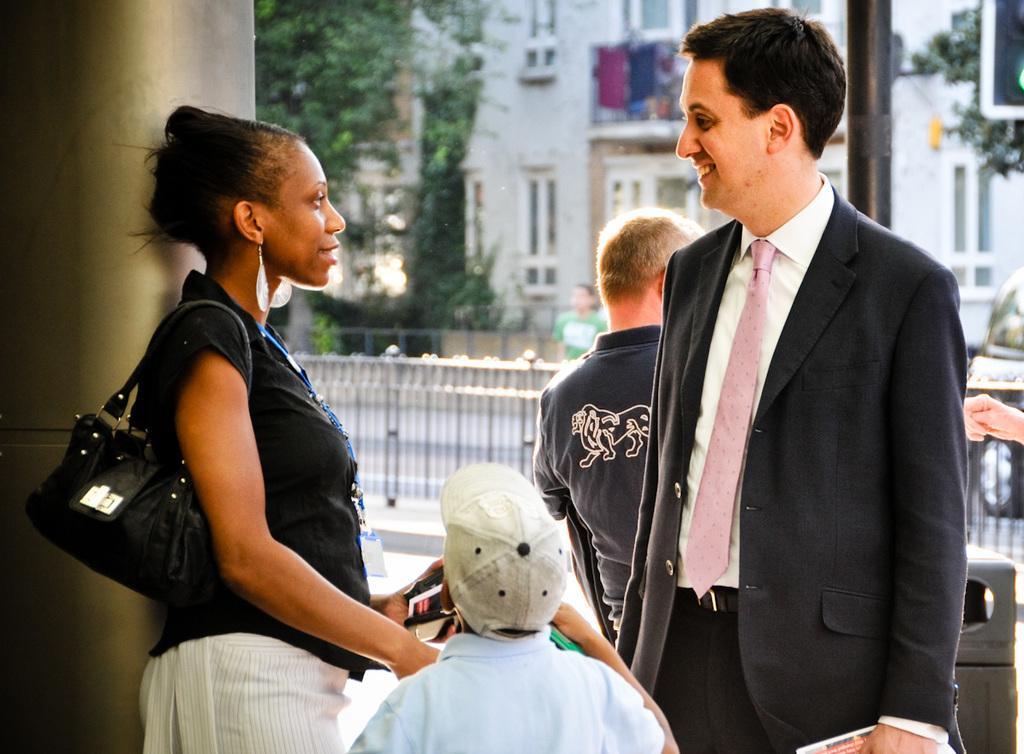In one or two sentences, can you explain what this image depicts? In this image I can see a man and a woman are standing, smiling and looking at each other. The man is wearing black color suit, white color shirt and a tie. He is holding some object in the hand. The woman is wearing black color shirt and holding a bag. At the bottom of the image I can see a person wearing t-shirt, cap on the head and looking at the woman. In the background there is another person is standing. Beside the woman I can see a pillar. In the background there is a building and some trees. In the middle of the image I can see a railing on the road. 